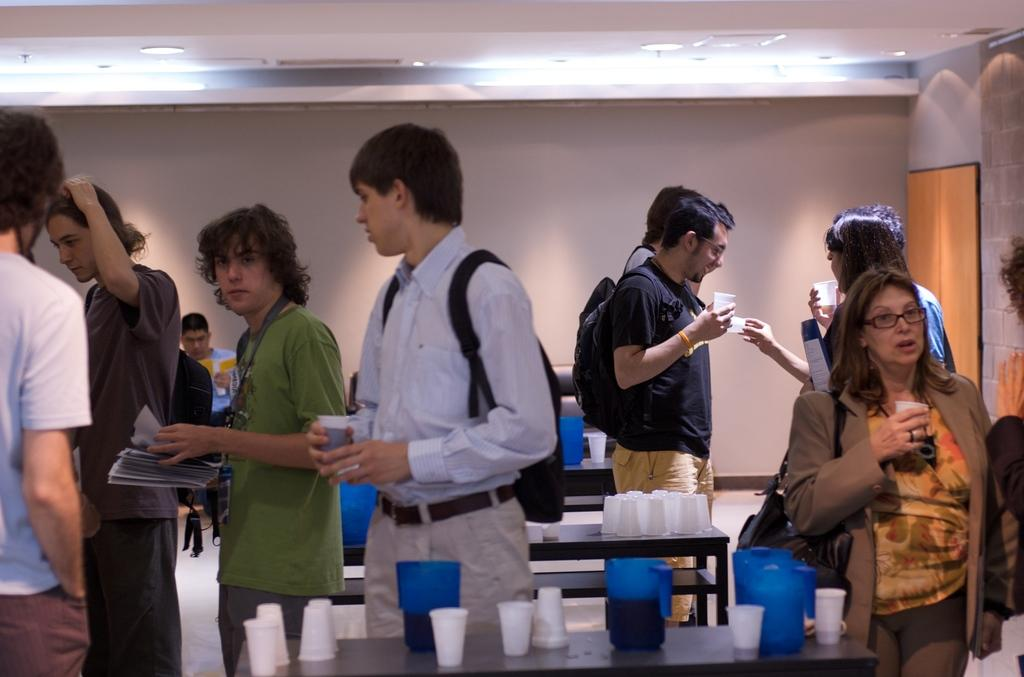Who or what is present in the image? There are people in the image. What type of furniture is visible in the image? There are tables in the image. What object can be seen besides the tables and people? There is a box in the image. What items are on the tables in the image? There are glasses on the table. What type of chin can be seen on the people in the image? There is no mention of chins in the provided facts, and we cannot determine the type of chin from the image. 